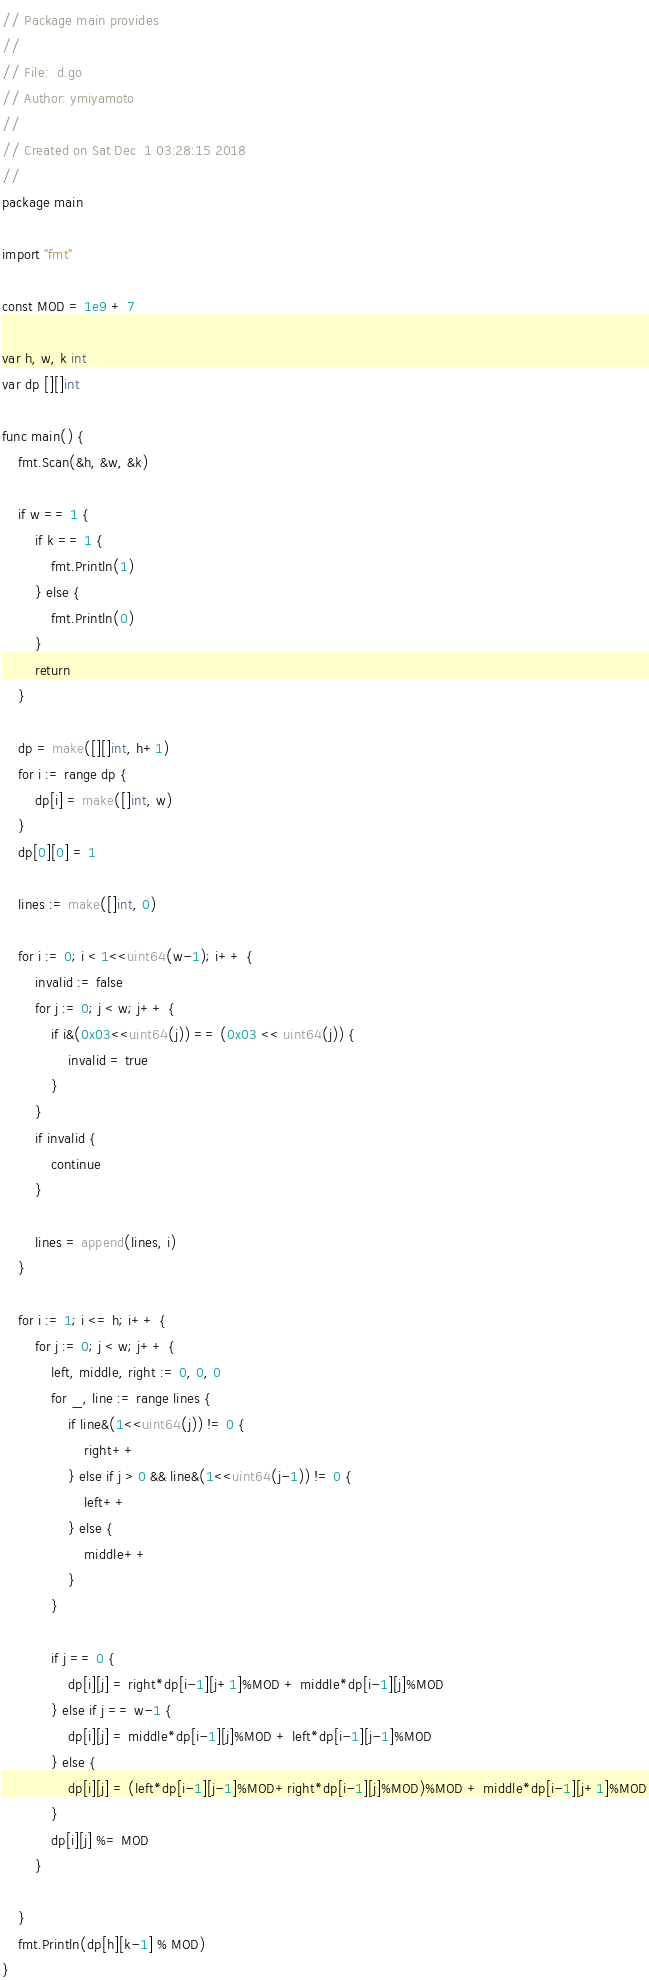Convert code to text. <code><loc_0><loc_0><loc_500><loc_500><_Go_>// Package main provides
//
// File:  d.go
// Author: ymiyamoto
//
// Created on Sat Dec  1 03:28:15 2018
//
package main

import "fmt"

const MOD = 1e9 + 7

var h, w, k int
var dp [][]int

func main() {
	fmt.Scan(&h, &w, &k)

	if w == 1 {
		if k == 1 {
			fmt.Println(1)
		} else {
			fmt.Println(0)
		}
		return
	}

	dp = make([][]int, h+1)
	for i := range dp {
		dp[i] = make([]int, w)
	}
	dp[0][0] = 1

	lines := make([]int, 0)

	for i := 0; i < 1<<uint64(w-1); i++ {
		invalid := false
		for j := 0; j < w; j++ {
			if i&(0x03<<uint64(j)) == (0x03 << uint64(j)) {
				invalid = true
			}
		}
		if invalid {
			continue
		}

		lines = append(lines, i)
	}

	for i := 1; i <= h; i++ {
		for j := 0; j < w; j++ {
			left, middle, right := 0, 0, 0
			for _, line := range lines {
				if line&(1<<uint64(j)) != 0 {
					right++
				} else if j > 0 && line&(1<<uint64(j-1)) != 0 {
					left++
				} else {
					middle++
				}
			}

			if j == 0 {
				dp[i][j] = right*dp[i-1][j+1]%MOD + middle*dp[i-1][j]%MOD
			} else if j == w-1 {
				dp[i][j] = middle*dp[i-1][j]%MOD + left*dp[i-1][j-1]%MOD
			} else {
				dp[i][j] = (left*dp[i-1][j-1]%MOD+right*dp[i-1][j]%MOD)%MOD + middle*dp[i-1][j+1]%MOD
			}
			dp[i][j] %= MOD
		}

	}
	fmt.Println(dp[h][k-1] % MOD)
}
</code> 